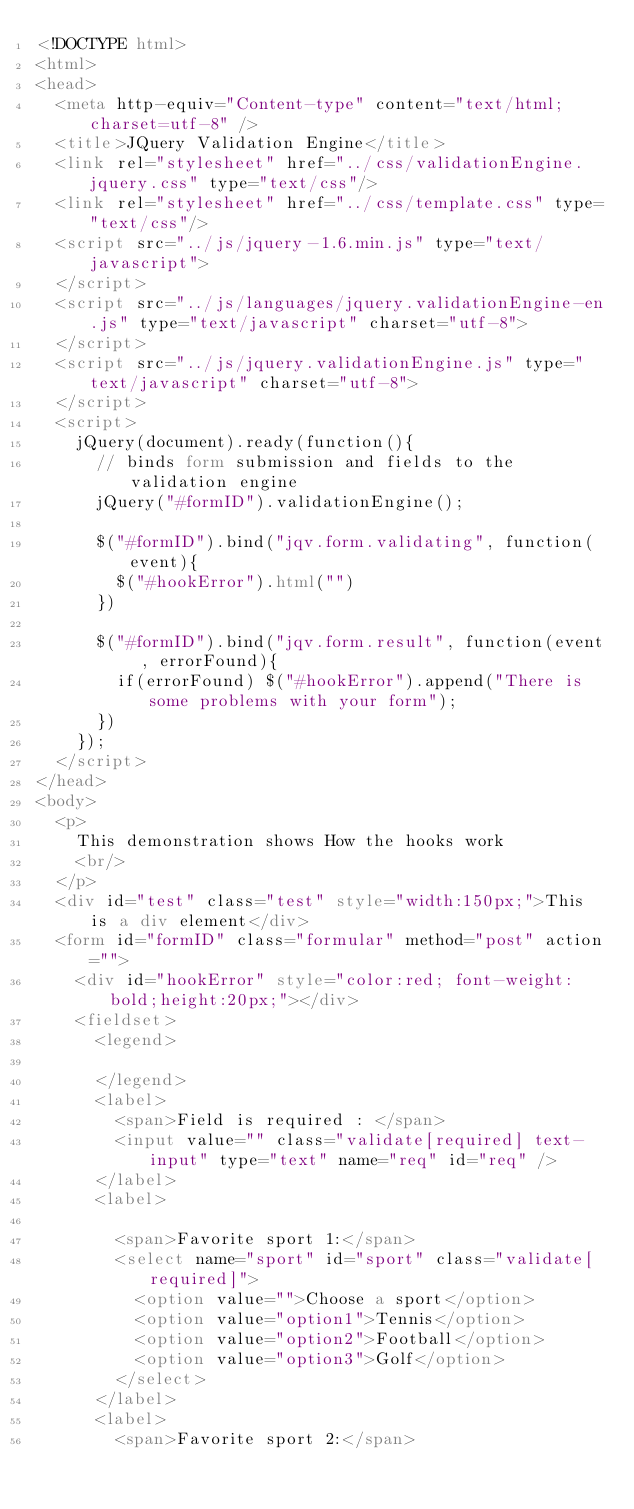Convert code to text. <code><loc_0><loc_0><loc_500><loc_500><_HTML_><!DOCTYPE html>
<html>
<head>
	<meta http-equiv="Content-type" content="text/html; charset=utf-8" />
	<title>JQuery Validation Engine</title>
	<link rel="stylesheet" href="../css/validationEngine.jquery.css" type="text/css"/>
	<link rel="stylesheet" href="../css/template.css" type="text/css"/>
	<script src="../js/jquery-1.6.min.js" type="text/javascript">
	</script>
	<script src="../js/languages/jquery.validationEngine-en.js" type="text/javascript" charset="utf-8">
	</script>
	<script src="../js/jquery.validationEngine.js" type="text/javascript" charset="utf-8">
	</script>
	<script>
		jQuery(document).ready(function(){
			// binds form submission and fields to the validation engine
			jQuery("#formID").validationEngine();

			$("#formID").bind("jqv.form.validating", function(event){
				$("#hookError").html("")
			})

			$("#formID").bind("jqv.form.result", function(event , errorFound){
				if(errorFound) $("#hookError").append("There is some problems with your form");
			})
		});
	</script>
</head>
<body>
	<p>
		This demonstration shows How the hooks work
		<br/>
	</p>
	<div id="test" class="test" style="width:150px;">This is a div element</div>
	<form id="formID" class="formular" method="post" action="">
		<div id="hookError" style="color:red; font-weight:bold;height:20px;"></div>
		<fieldset>
			<legend>
                    
			</legend>
			<label>
				<span>Field is required : </span>
				<input value="" class="validate[required] text-input" type="text" name="req" id="req" />
			</label>
			<label>
                	
				<span>Favorite sport 1:</span>
				<select name="sport" id="sport" class="validate[required]">
					<option value="">Choose a sport</option>
					<option value="option1">Tennis</option>
					<option value="option2">Football</option>
					<option value="option3">Golf</option>
				</select>
			</label>
			<label>
				<span>Favorite sport 2:</span></code> 